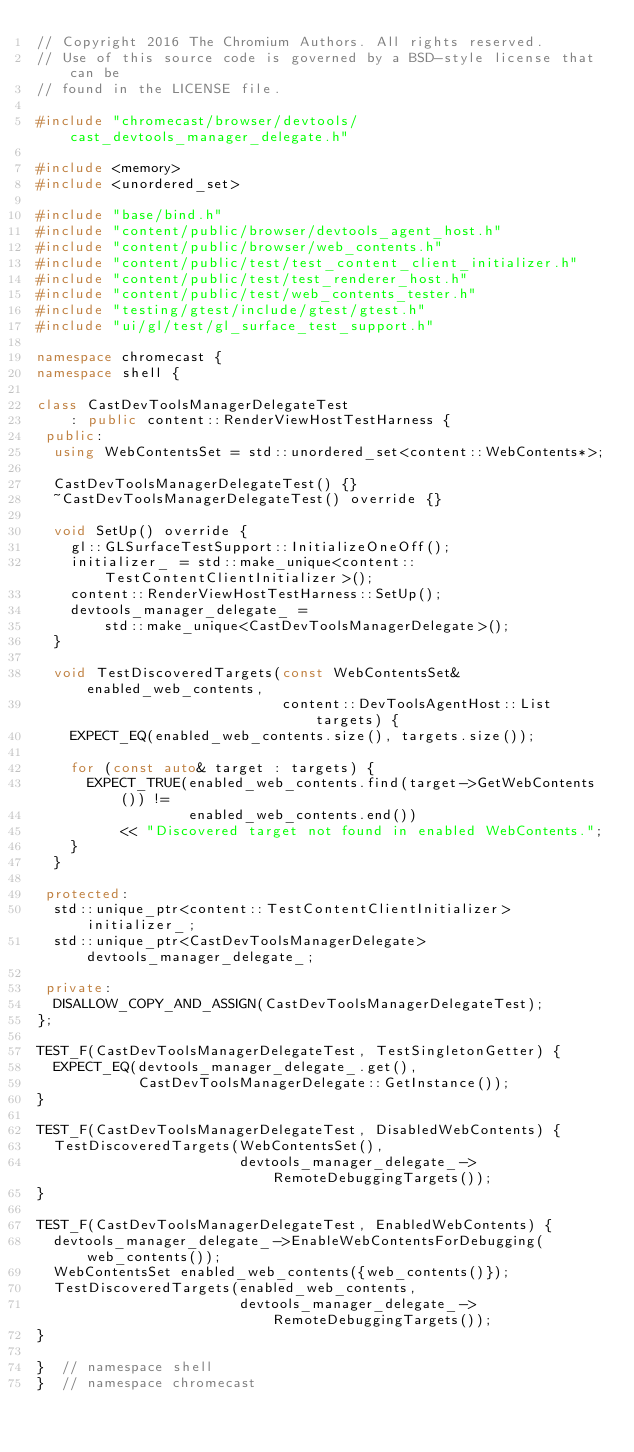<code> <loc_0><loc_0><loc_500><loc_500><_C++_>// Copyright 2016 The Chromium Authors. All rights reserved.
// Use of this source code is governed by a BSD-style license that can be
// found in the LICENSE file.

#include "chromecast/browser/devtools/cast_devtools_manager_delegate.h"

#include <memory>
#include <unordered_set>

#include "base/bind.h"
#include "content/public/browser/devtools_agent_host.h"
#include "content/public/browser/web_contents.h"
#include "content/public/test/test_content_client_initializer.h"
#include "content/public/test/test_renderer_host.h"
#include "content/public/test/web_contents_tester.h"
#include "testing/gtest/include/gtest/gtest.h"
#include "ui/gl/test/gl_surface_test_support.h"

namespace chromecast {
namespace shell {

class CastDevToolsManagerDelegateTest
    : public content::RenderViewHostTestHarness {
 public:
  using WebContentsSet = std::unordered_set<content::WebContents*>;

  CastDevToolsManagerDelegateTest() {}
  ~CastDevToolsManagerDelegateTest() override {}

  void SetUp() override {
    gl::GLSurfaceTestSupport::InitializeOneOff();
    initializer_ = std::make_unique<content::TestContentClientInitializer>();
    content::RenderViewHostTestHarness::SetUp();
    devtools_manager_delegate_ =
        std::make_unique<CastDevToolsManagerDelegate>();
  }

  void TestDiscoveredTargets(const WebContentsSet& enabled_web_contents,
                             content::DevToolsAgentHost::List targets) {
    EXPECT_EQ(enabled_web_contents.size(), targets.size());

    for (const auto& target : targets) {
      EXPECT_TRUE(enabled_web_contents.find(target->GetWebContents()) !=
                  enabled_web_contents.end())
          << "Discovered target not found in enabled WebContents.";
    }
  }

 protected:
  std::unique_ptr<content::TestContentClientInitializer> initializer_;
  std::unique_ptr<CastDevToolsManagerDelegate> devtools_manager_delegate_;

 private:
  DISALLOW_COPY_AND_ASSIGN(CastDevToolsManagerDelegateTest);
};

TEST_F(CastDevToolsManagerDelegateTest, TestSingletonGetter) {
  EXPECT_EQ(devtools_manager_delegate_.get(),
            CastDevToolsManagerDelegate::GetInstance());
}

TEST_F(CastDevToolsManagerDelegateTest, DisabledWebContents) {
  TestDiscoveredTargets(WebContentsSet(),
                        devtools_manager_delegate_->RemoteDebuggingTargets());
}

TEST_F(CastDevToolsManagerDelegateTest, EnabledWebContents) {
  devtools_manager_delegate_->EnableWebContentsForDebugging(web_contents());
  WebContentsSet enabled_web_contents({web_contents()});
  TestDiscoveredTargets(enabled_web_contents,
                        devtools_manager_delegate_->RemoteDebuggingTargets());
}

}  // namespace shell
}  // namespace chromecast
</code> 